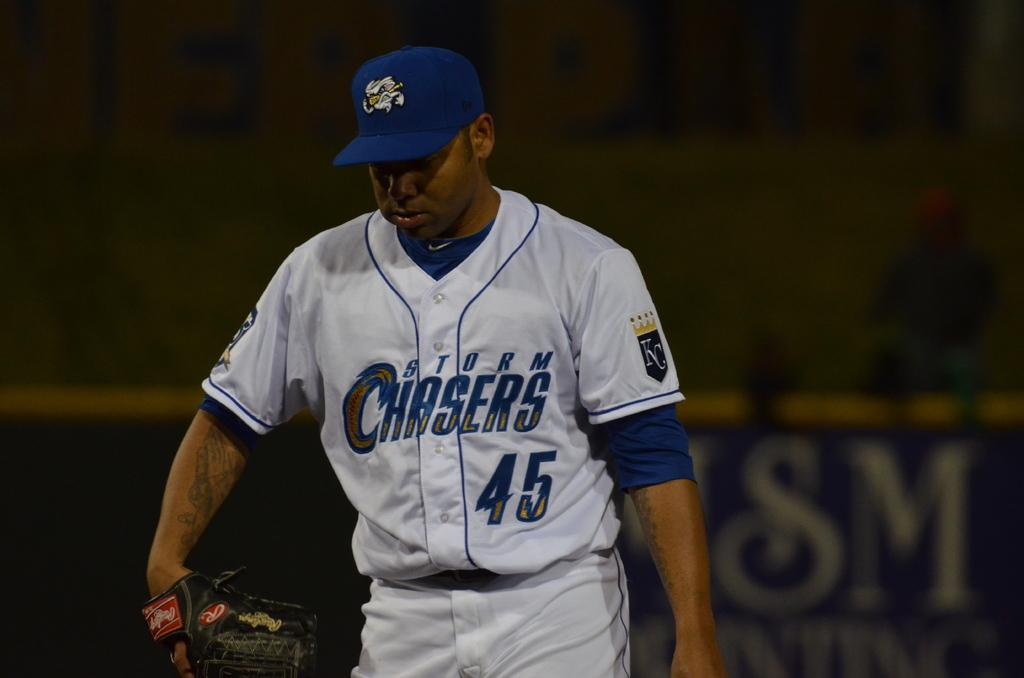<image>
Share a concise interpretation of the image provided. The player shown plays for the storm chasers. 